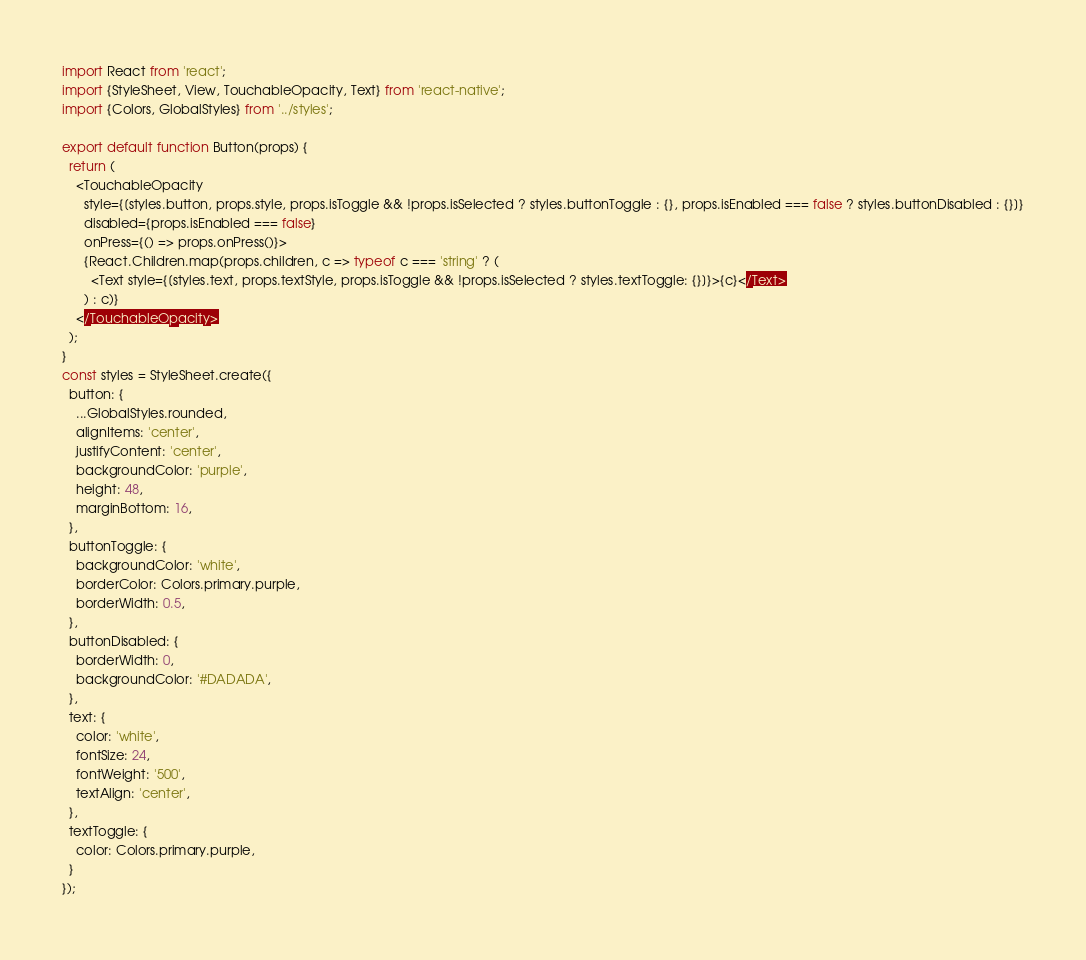<code> <loc_0><loc_0><loc_500><loc_500><_JavaScript_>import React from 'react';
import {StyleSheet, View, TouchableOpacity, Text} from 'react-native';
import {Colors, GlobalStyles} from '../styles';

export default function Button(props) {
  return (
    <TouchableOpacity
      style={[styles.button, props.style, props.isToggle && !props.isSelected ? styles.buttonToggle : {}, props.isEnabled === false ? styles.buttonDisabled : {}]}
      disabled={props.isEnabled === false}
      onPress={() => props.onPress()}>
      {React.Children.map(props.children, c => typeof c === 'string' ? (
        <Text style={[styles.text, props.textStyle, props.isToggle && !props.isSelected ? styles.textToggle: {}]}>{c}</Text>
      ) : c)}
    </TouchableOpacity>
  );
}
const styles = StyleSheet.create({
  button: {
    ...GlobalStyles.rounded,
    alignItems: 'center',
    justifyContent: 'center',
    backgroundColor: 'purple',
    height: 48,
    marginBottom: 16,
  },
  buttonToggle: {
    backgroundColor: 'white',
    borderColor: Colors.primary.purple,
    borderWidth: 0.5,
  },
  buttonDisabled: {
    borderWidth: 0,
    backgroundColor: '#DADADA',
  },
  text: {
    color: 'white',
    fontSize: 24,
    fontWeight: '500',
    textAlign: 'center',
  },
  textToggle: {
    color: Colors.primary.purple,
  }
});
</code> 